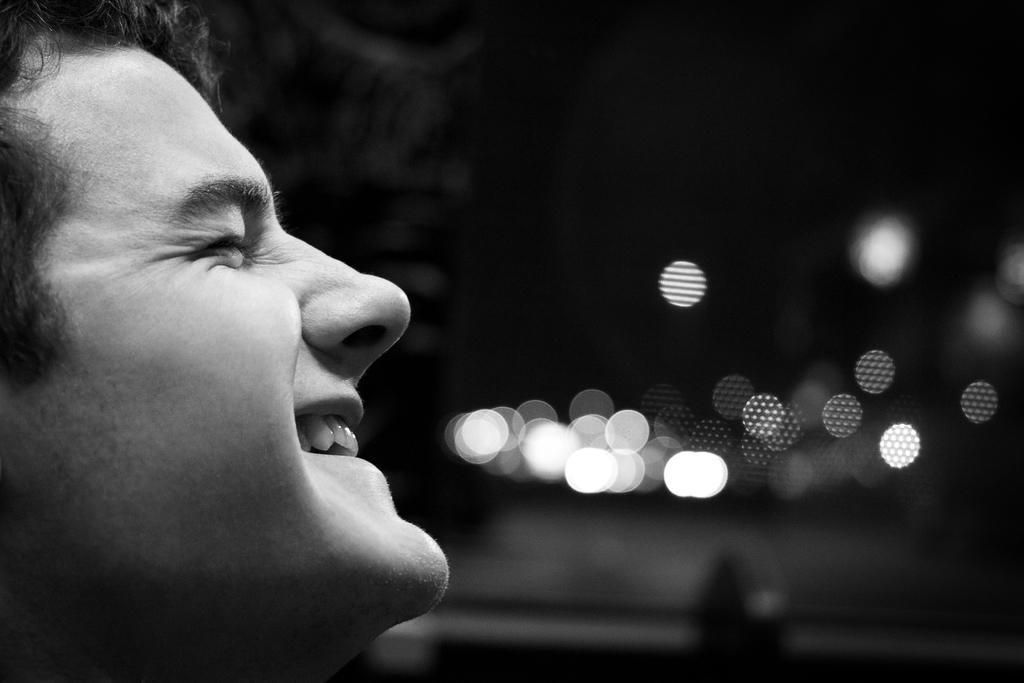What is the main subject in the foreground of the image? There is a man's face in the foreground of the image. How would you describe the background of the image? The background of the image is blurred. Are there any specific areas in the image that are in focus? Yes, there are some light focus areas in the image. What month does the man's mind represent in the image? The image does not depict a month or any representation of time, and there is no indication of the man's mind being present in the image. 